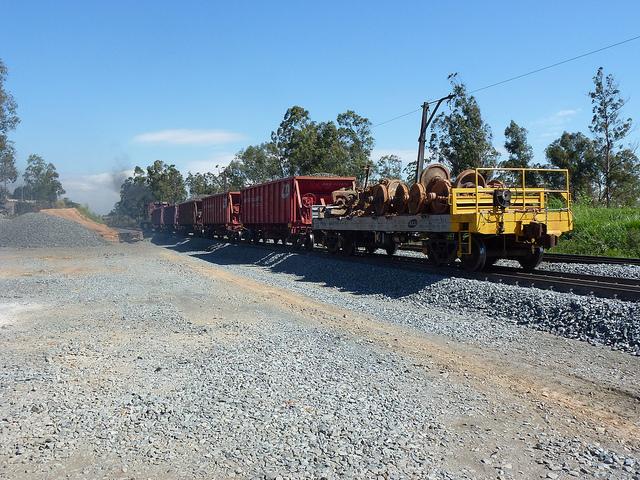Is this train moving forward?
Short answer required. Yes. How many trees are in this picture?
Answer briefly. 15. Is there a power line in this picture?
Be succinct. Yes. 